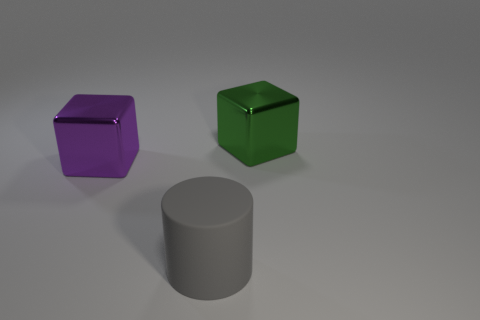Add 1 tiny brown rubber cylinders. How many objects exist? 4 Subtract all blocks. How many objects are left? 1 Subtract 1 cylinders. How many cylinders are left? 0 Add 2 gray rubber objects. How many gray rubber objects exist? 3 Subtract 0 green cylinders. How many objects are left? 3 Subtract all yellow cubes. Subtract all gray balls. How many cubes are left? 2 Subtract all brown spheres. How many cyan cylinders are left? 0 Subtract all large green things. Subtract all green cylinders. How many objects are left? 2 Add 2 big cylinders. How many big cylinders are left? 3 